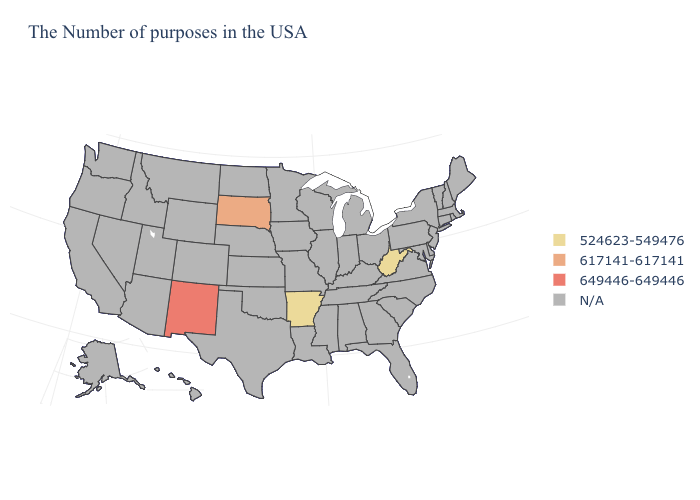What is the lowest value in the USA?
Write a very short answer. 524623-549476. What is the value of Missouri?
Answer briefly. N/A. What is the value of Idaho?
Write a very short answer. N/A. What is the value of Michigan?
Concise answer only. N/A. Which states have the lowest value in the USA?
Short answer required. West Virginia, Arkansas. What is the value of Missouri?
Quick response, please. N/A. Which states have the lowest value in the MidWest?
Be succinct. South Dakota. Does the first symbol in the legend represent the smallest category?
Give a very brief answer. Yes. Name the states that have a value in the range N/A?
Give a very brief answer. Maine, Massachusetts, Rhode Island, New Hampshire, Vermont, Connecticut, New York, New Jersey, Delaware, Maryland, Pennsylvania, Virginia, North Carolina, South Carolina, Ohio, Florida, Georgia, Michigan, Kentucky, Indiana, Alabama, Tennessee, Wisconsin, Illinois, Mississippi, Louisiana, Missouri, Minnesota, Iowa, Kansas, Nebraska, Oklahoma, Texas, North Dakota, Wyoming, Colorado, Utah, Montana, Arizona, Idaho, Nevada, California, Washington, Oregon, Alaska, Hawaii. What is the value of Arizona?
Give a very brief answer. N/A. What is the value of Colorado?
Concise answer only. N/A. Which states have the lowest value in the USA?
Short answer required. West Virginia, Arkansas. What is the lowest value in the West?
Keep it brief. 649446-649446. Does New Mexico have the lowest value in the USA?
Write a very short answer. No. 